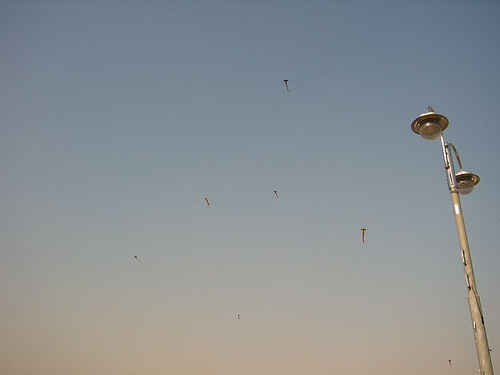Describe the objects in this image and their specific colors. I can see kite in gray, darkgray, brown, and maroon tones, kite in gray and black tones, kite in gray, darkgray, and black tones, kite in gray, darkgray, and black tones, and kite in darkgray, gray, and black tones in this image. 